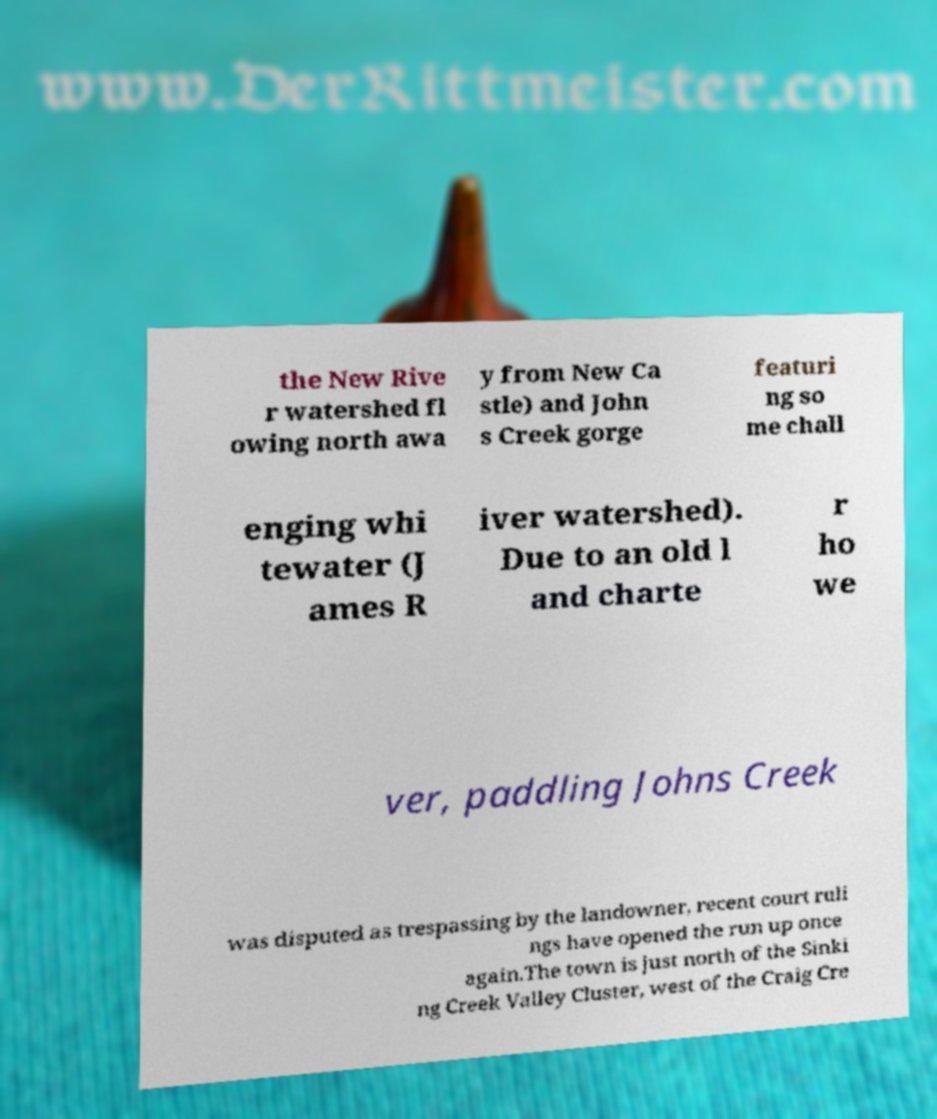Can you read and provide the text displayed in the image?This photo seems to have some interesting text. Can you extract and type it out for me? the New Rive r watershed fl owing north awa y from New Ca stle) and John s Creek gorge featuri ng so me chall enging whi tewater (J ames R iver watershed). Due to an old l and charte r ho we ver, paddling Johns Creek was disputed as trespassing by the landowner, recent court ruli ngs have opened the run up once again.The town is just north of the Sinki ng Creek Valley Cluster, west of the Craig Cre 